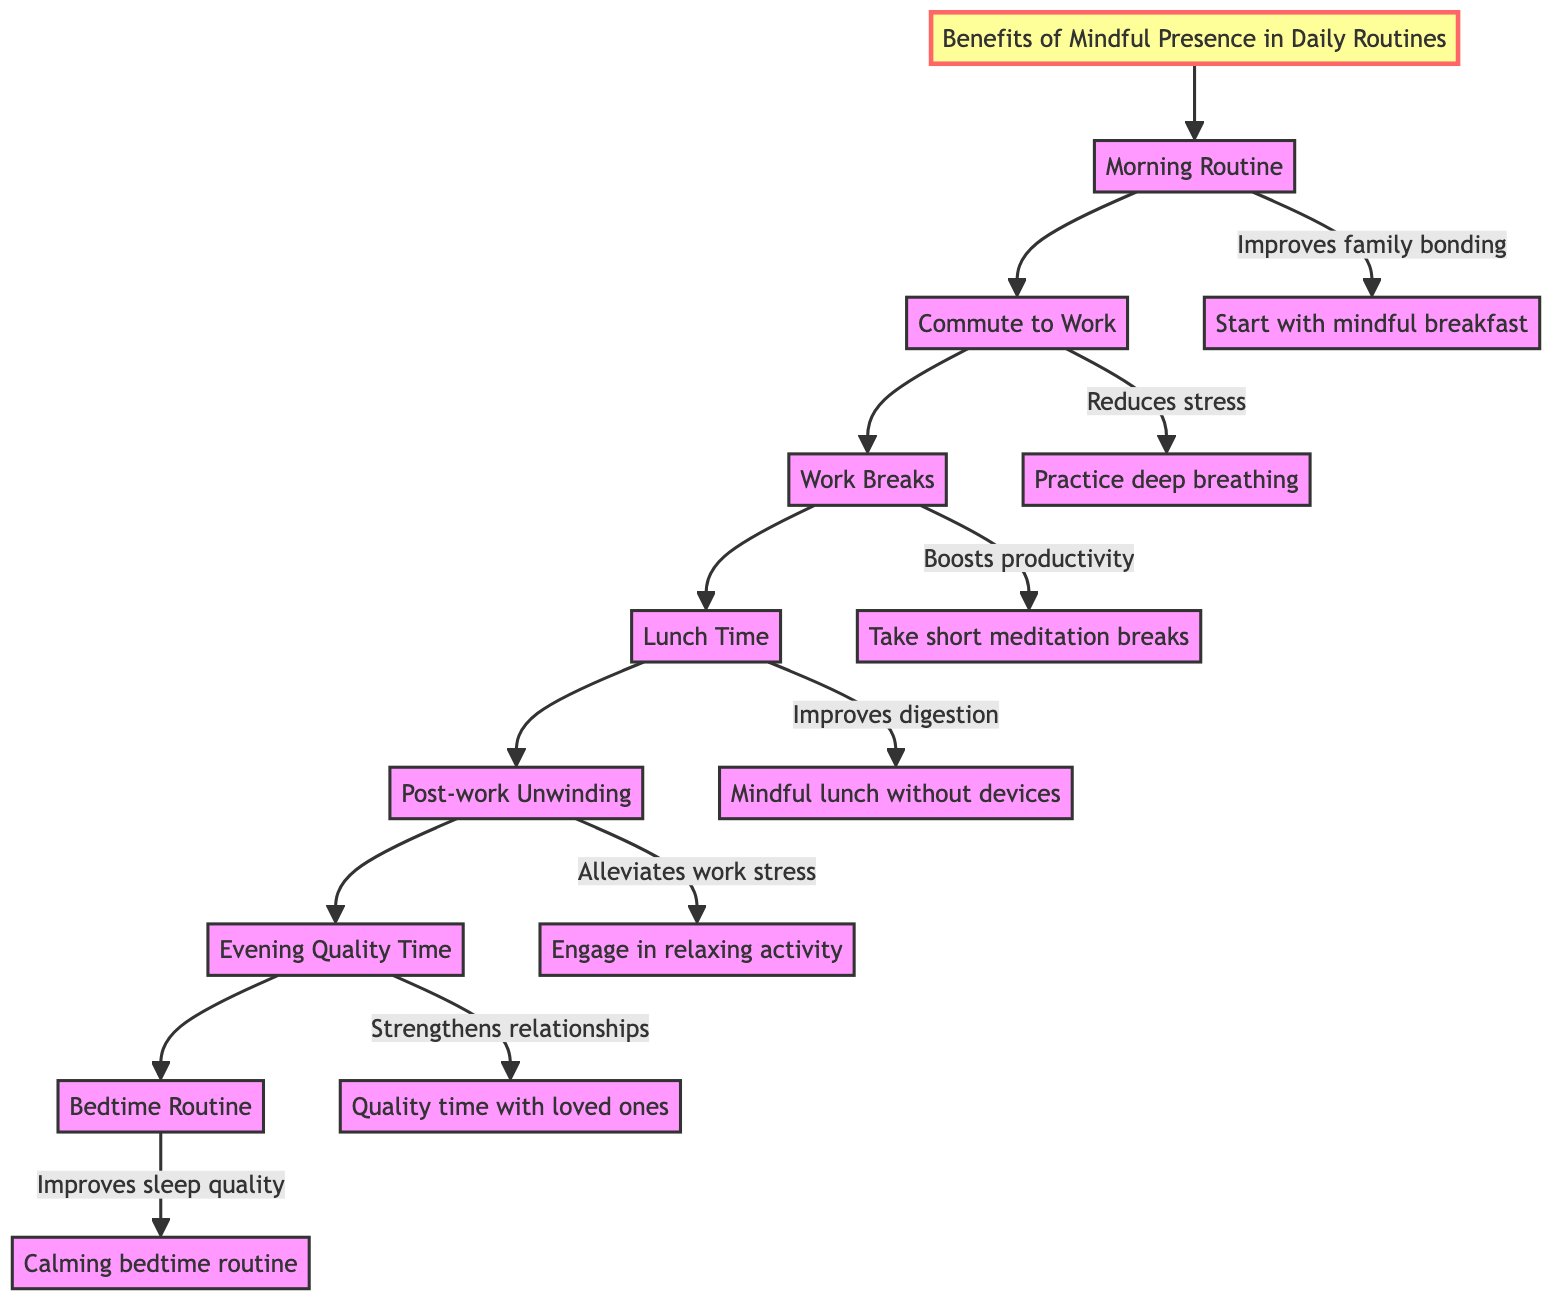What is the first step in the clinical pathway? The diagram indicates the first step is "Morning Routine," which is represented at the top of the flowchart.
Answer: Morning Routine How many steps are in the pathway? The sequence of steps in the diagram shows a total of 7 distinct steps from the "Morning Routine" to the "Bedtime Routine."
Answer: 7 What benefit is associated with the "Lunch Time" step? The diagram links the "Lunch Time" step to the benefit of "Improves digestion," and this is specifically stated next to that node in the flowchart.
Answer: Improves digestion Which step follows "Post-work Unwinding"? The flowchart shows that the step "Evening Quality Time" directly follows "Post-work Unwinding," providing a sequential connection between these steps.
Answer: Evening Quality Time What is the benefit of taking breaks during work? The diagram states that taking breaks boosts productivity, which is specifically noted next to the "Work Breaks" step.
Answer: Boosts productivity What is the last step in the clinical pathway? The last node in the sequence is "Bedtime Routine," which appears at the bottom of the flowchart, indicating it’s the final step in the pathway.
Answer: Bedtime Routine What is one activity suggested during the commute to work? The diagram suggests practicing deep breathing during the "Commute to Work" step, highlighting it as a mindful activity to engage in.
Answer: Practice deep breathing Which step emphasizes the importance of family interaction? The "Evening Quality Time" step emphasizes family interaction, as it involves spending quality time with loved ones.
Answer: Evening Quality Time 